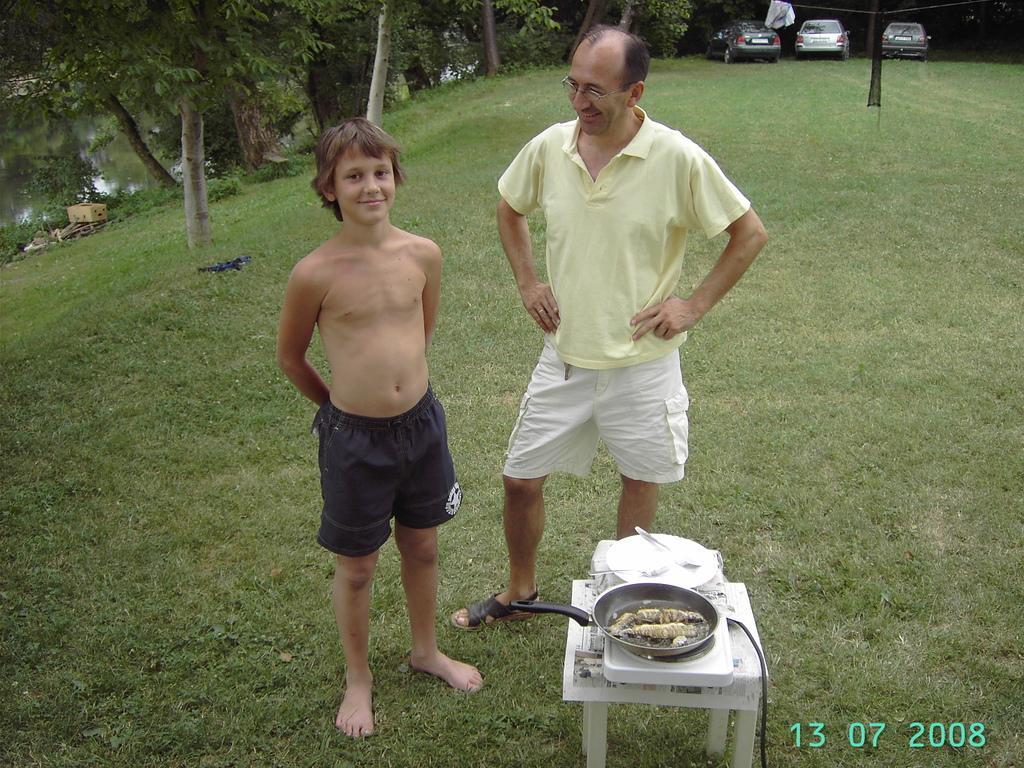Describe this image in one or two sentences. In this image, we can see people standing and one of them is wearing glasses and there is a pan containing food and a plate are placed on the stove and there is a table. In the background, there are trees and we can see vehicles on the ground and we can see clothes hanging to the rope and there is a pole. At the bottom, we can see some text. 